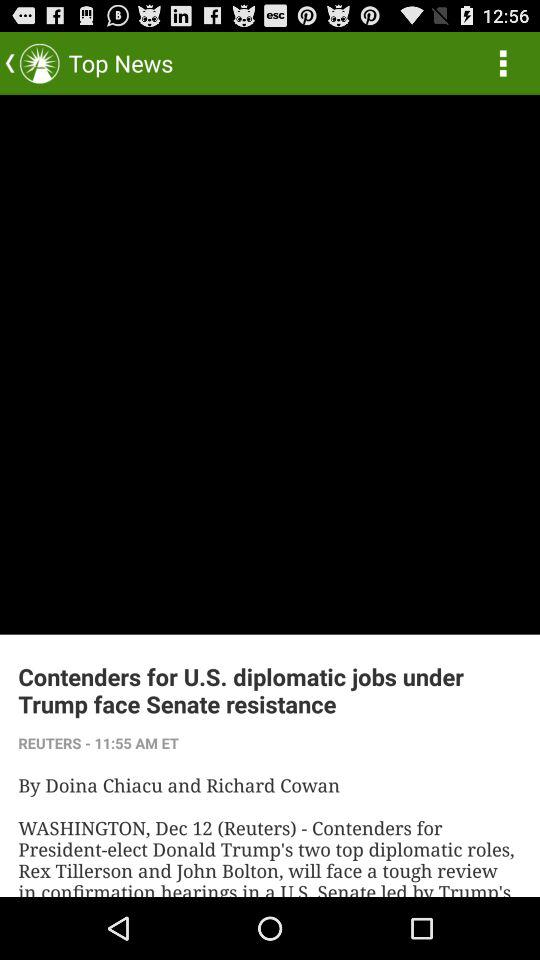Who is the author of the article? The authors of the article are Doina Chiacu and Richard Cowan. 